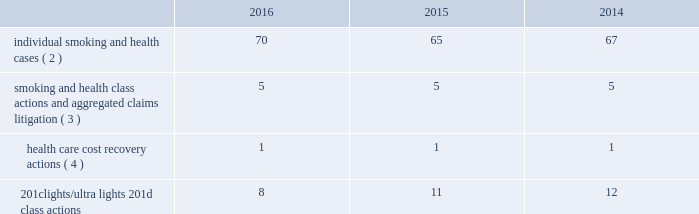Altria group , inc .
And subsidiaries notes to consolidated financial statements _________________________ may not be obtainable in all cases .
This risk has been substantially reduced given that 47 states and puerto rico limit the dollar amount of bonds or require no bond at all .
As discussed below , however , tobacco litigation plaintiffs have challenged the constitutionality of florida 2019s bond cap statute in several cases and plaintiffs may challenge state bond cap statutes in other jurisdictions as well .
Such challenges may include the applicability of state bond caps in federal court .
States , including florida , may also seek to repeal or alter bond cap statutes through legislation .
Although altria group , inc .
Cannot predict the outcome of such challenges , it is possible that the consolidated results of operations , cash flows or financial position of altria group , inc. , or one or more of its subsidiaries , could be materially affected in a particular fiscal quarter or fiscal year by an unfavorable outcome of one or more such challenges .
Altria group , inc .
And its subsidiaries record provisions in the consolidated financial statements for pending litigation when they determine that an unfavorable outcome is probable and the amount of the loss can be reasonably estimated .
At the present time , while it is reasonably possible that an unfavorable outcome in a case may occur , except to the extent discussed elsewhere in this note 19 .
Contingencies : ( i ) management has concluded that it is not probable that a loss has been incurred in any of the pending tobacco-related cases ; ( ii ) management is unable to estimate the possible loss or range of loss that could result from an unfavorable outcome in any of the pending tobacco-related cases ; and ( iii ) accordingly , management has not provided any amounts in the consolidated financial statements for unfavorable outcomes , if any .
Litigation defense costs are expensed as incurred .
Altria group , inc .
And its subsidiaries have achieved substantial success in managing litigation .
Nevertheless , litigation is subject to uncertainty and significant challenges remain .
It is possible that the consolidated results of operations , cash flows or financial position of altria group , inc. , or one or more of its subsidiaries , could be materially affected in a particular fiscal quarter or fiscal year by an unfavorable outcome or settlement of certain pending litigation .
Altria group , inc .
And each of its subsidiaries named as a defendant believe , and each has been so advised by counsel handling the respective cases , that it has valid defenses to the litigation pending against it , as well as valid bases for appeal of adverse verdicts .
Each of the companies has defended , and will continue to defend , vigorously against litigation challenges .
However , altria group , inc .
And its subsidiaries may enter into settlement discussions in particular cases if they believe it is in the best interests of altria group , inc .
To do so .
Overview of altria group , inc .
And/or pm usa tobacco- related litigation types and number of cases : claims related to tobacco products generally fall within the following categories : ( i ) smoking and health cases alleging personal injury brought on behalf of individual plaintiffs ; ( ii ) smoking and health cases primarily alleging personal injury or seeking court-supervised programs for ongoing medical monitoring and purporting to be brought on behalf of a class of individual plaintiffs , including cases in which the aggregated claims of a number of individual plaintiffs are to be tried in a single proceeding ; ( iii ) health care cost recovery cases brought by governmental ( both domestic and foreign ) plaintiffs seeking reimbursement for health care expenditures allegedly caused by cigarette smoking and/or disgorgement of profits ; ( iv ) class action suits alleging that the uses of the terms 201clights 201d and 201cultra lights 201d constitute deceptive and unfair trade practices , common law or statutory fraud , unjust enrichment , breach of warranty or violations of the racketeer influenced and corrupt organizations act ( 201crico 201d ) ; and ( v ) other tobacco-related litigation described below .
Plaintiffs 2019 theories of recovery and the defenses raised in pending smoking and health , health care cost recovery and 201clights/ultra lights 201d cases are discussed below .
The table below lists the number of certain tobacco-related cases pending in the united states against pm usa ( 1 ) and , in some instances , altria group , inc .
As of december 31 , 2016 , 2015 and 2014: .
( 1 ) does not include 25 cases filed on the asbestos docket in the circuit court for baltimore city , maryland , which seek to join pm usa and other cigarette- manufacturing defendants in complaints previously filed against asbestos companies .
( 2 ) does not include 2485 cases brought by flight attendants seeking compensatory damages for personal injuries allegedly caused by exposure to environmental tobacco smoke ( 201cets 201d ) .
The flight attendants allege that they are members of an ets smoking and health class action in florida , which was settled in 1997 ( broin ) .
The terms of the court-approved settlement in that case allowed class members to file individual lawsuits seeking compensatory damages , but prohibited them from seeking punitive damages .
Also , does not include individual smoking and health cases brought by or on behalf of plaintiffs in florida state and federal courts following the decertification of the engle case ( discussed below in smoking and health litigation - engle class action ) .
( 3 ) includes as one case the 600 civil actions ( of which 344 were actions against pm usa ) that were to be tried in a single proceeding in west virginia ( in re : tobacco litigation ) .
The west virginia supreme court of appeals ruled that the united states constitution did not preclude a trial in two phases in this case .
Issues related to defendants 2019 conduct and whether punitive damages are permissible were tried in the first phase .
Trial in the first phase of this case began in april 2013 .
In may 2013 , the jury returned a verdict in favor of defendants on the claims for design defect , negligence , failure to warn , breach of warranty , and concealment and declined to find that the defendants 2019 conduct warranted punitive damages .
Plaintiffs prevailed on their claim that ventilated filter cigarettes should have included use instructions for the period 1964 - 1969 .
The second phase will consist of trials to determine liability and compensatory damages .
In november 2014 , the west virginia supreme court of appeals affirmed the final judgment .
In july 2015 , the trial court entered an order that will result in the entry of final judgment in favor of defendants and against all but 30 plaintiffs who potentially have a claim against one or more defendants that may be pursued in a second phase of trial .
The court intends to try the claims of these 30 plaintiffs in six consolidated trials , each with a group of five plaintiffs .
The first trial is currently scheduled to begin may 1 , 2018 .
Dates for the five remaining consolidated trials have not been scheduled .
( 4 ) see health care cost recovery litigation - federal government 2019s lawsuit below. .
How many total cases are pending as of 12/31/16? 
Computations: (((70 + 5) + 1) + 8)
Answer: 84.0. 